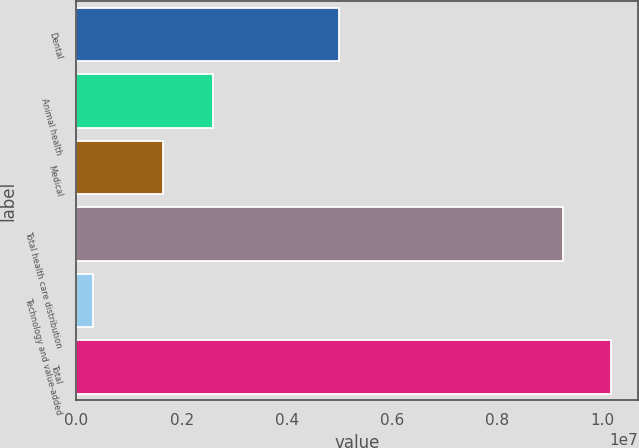Convert chart. <chart><loc_0><loc_0><loc_500><loc_500><bar_chart><fcel>Dental<fcel>Animal health<fcel>Medical<fcel>Total health care distribution<fcel>Technology and value-added<fcel>Total<nl><fcel>4.99797e+06<fcel>2.59946e+06<fcel>1.64317e+06<fcel>9.2406e+06<fcel>320047<fcel>1.01647e+07<nl></chart> 